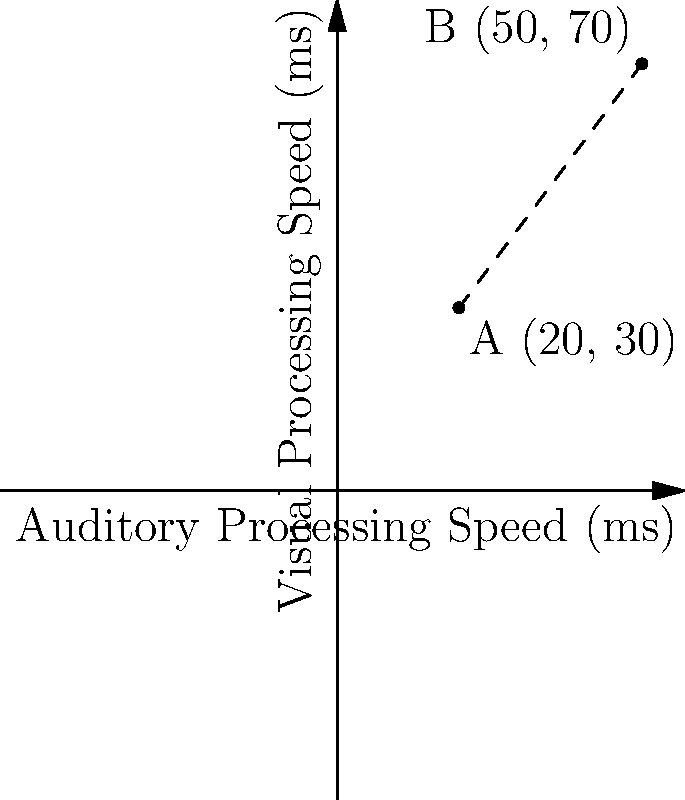In a study on sensory processing speeds, two individuals with different sensory processing disorders were assessed. Their auditory and visual processing speeds (in milliseconds) are represented as points A(20, 30) and B(50, 70) on the graph. Calculate the Euclidean distance between these two points to determine the overall difference in their sensory processing speeds. To calculate the Euclidean distance between two points, we use the distance formula:

$$d = \sqrt{(x_2 - x_1)^2 + (y_2 - y_1)^2}$$

Where $(x_1, y_1)$ represents the coordinates of point A, and $(x_2, y_2)$ represents the coordinates of point B.

Step 1: Identify the coordinates
Point A: $(x_1, y_1) = (20, 30)$
Point B: $(x_2, y_2) = (50, 70)$

Step 2: Substitute the values into the formula
$$d = \sqrt{(50 - 20)^2 + (70 - 30)^2}$$

Step 3: Simplify the expressions inside the parentheses
$$d = \sqrt{(30)^2 + (40)^2}$$

Step 4: Calculate the squares
$$d = \sqrt{900 + 1600}$$

Step 5: Add the values under the square root
$$d = \sqrt{2500}$$

Step 6: Simplify the square root
$$d = 50$$

Therefore, the Euclidean distance between points A and B is 50 milliseconds.
Answer: 50 ms 